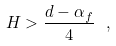Convert formula to latex. <formula><loc_0><loc_0><loc_500><loc_500>H > \frac { d - \alpha _ { f } } { 4 } \ ,</formula> 